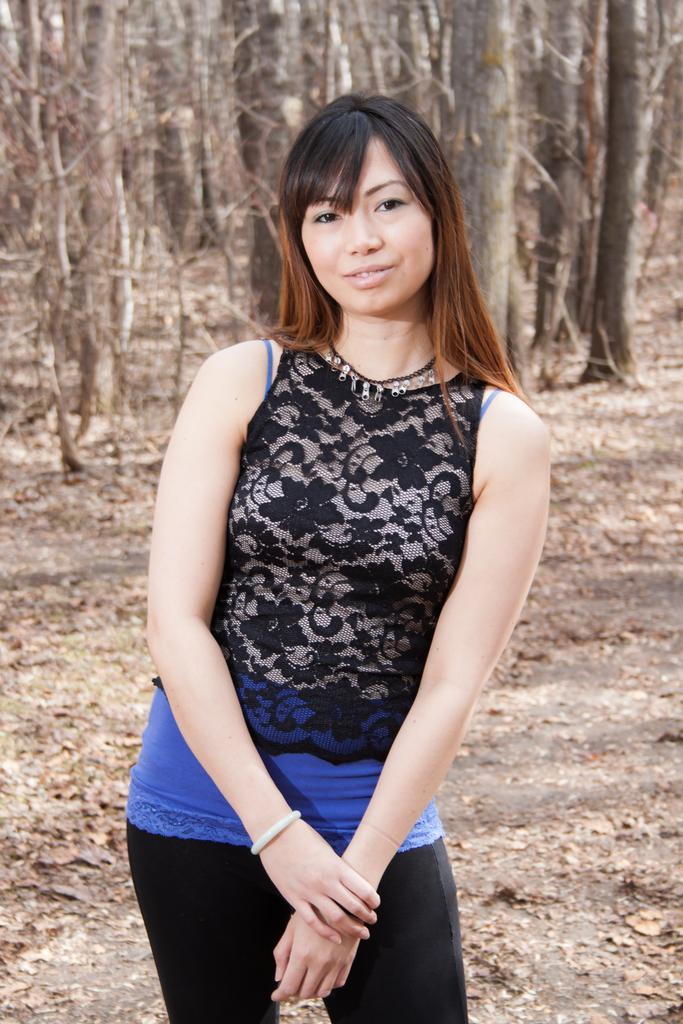Who is present in the image? There is a woman in the image. What is the woman doing in the image? The woman is standing in the image. What type of surface is visible beneath the woman? There is ground visible in the image. What can be seen growing on the ground in the image? There are trees on the ground in the image. What point is the woman making in the bedroom in the image? There is no bedroom present in the image, and the woman is not making any points; she is simply standing. 